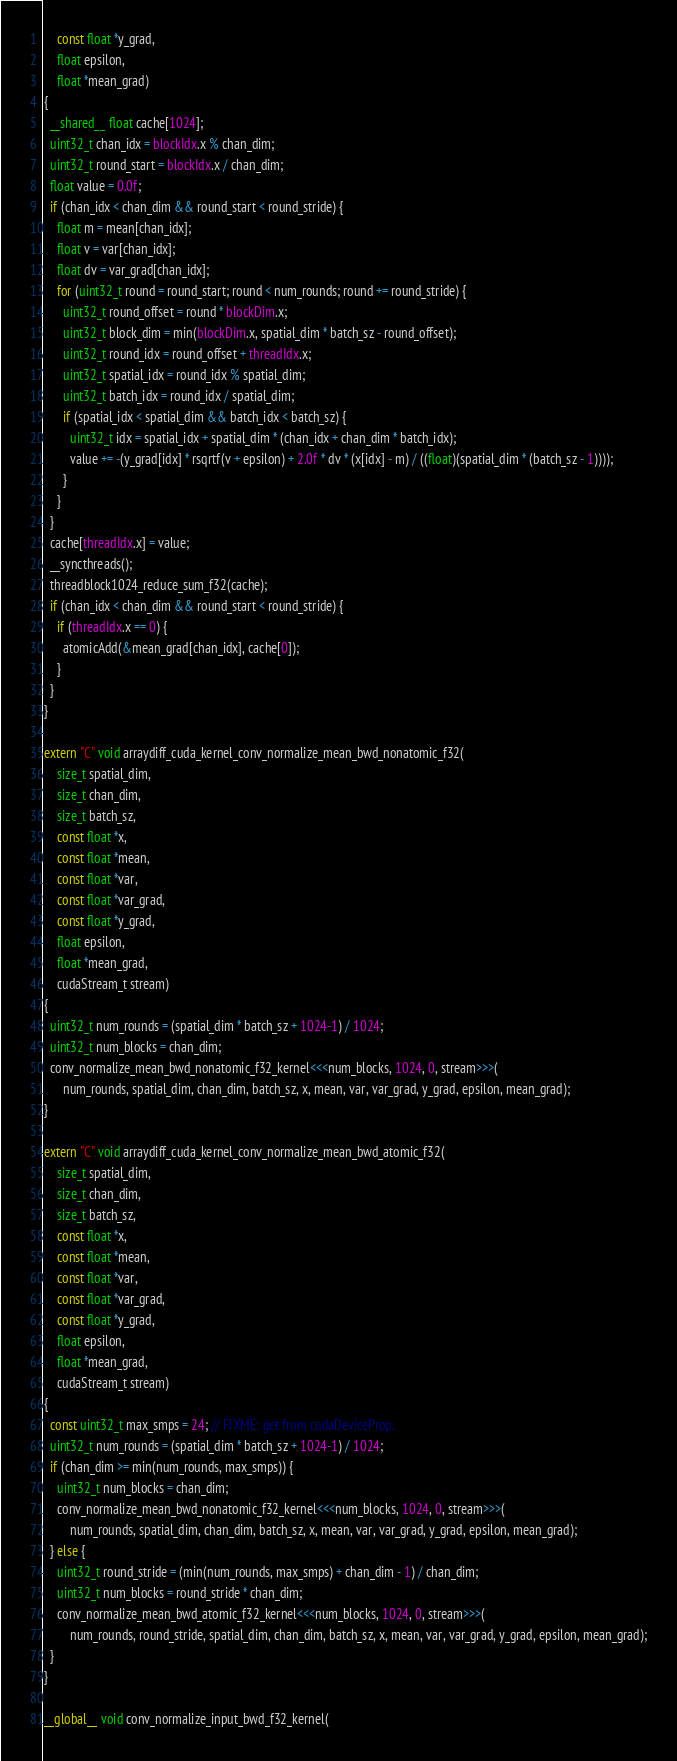Convert code to text. <code><loc_0><loc_0><loc_500><loc_500><_Cuda_>    const float *y_grad,
    float epsilon,
    float *mean_grad)
{
  __shared__ float cache[1024];
  uint32_t chan_idx = blockIdx.x % chan_dim;
  uint32_t round_start = blockIdx.x / chan_dim;
  float value = 0.0f;
  if (chan_idx < chan_dim && round_start < round_stride) {
    float m = mean[chan_idx];
    float v = var[chan_idx];
    float dv = var_grad[chan_idx];
    for (uint32_t round = round_start; round < num_rounds; round += round_stride) {
      uint32_t round_offset = round * blockDim.x;
      uint32_t block_dim = min(blockDim.x, spatial_dim * batch_sz - round_offset);
      uint32_t round_idx = round_offset + threadIdx.x;
      uint32_t spatial_idx = round_idx % spatial_dim;
      uint32_t batch_idx = round_idx / spatial_dim;
      if (spatial_idx < spatial_dim && batch_idx < batch_sz) {
        uint32_t idx = spatial_idx + spatial_dim * (chan_idx + chan_dim * batch_idx);
        value += -(y_grad[idx] * rsqrtf(v + epsilon) + 2.0f * dv * (x[idx] - m) / ((float)(spatial_dim * (batch_sz - 1))));
      }
    }
  }
  cache[threadIdx.x] = value;
  __syncthreads();
  threadblock1024_reduce_sum_f32(cache);
  if (chan_idx < chan_dim && round_start < round_stride) {
    if (threadIdx.x == 0) {
      atomicAdd(&mean_grad[chan_idx], cache[0]);
    }
  }
}

extern "C" void arraydiff_cuda_kernel_conv_normalize_mean_bwd_nonatomic_f32(
    size_t spatial_dim,
    size_t chan_dim,
    size_t batch_sz,
    const float *x,
    const float *mean,
    const float *var,
    const float *var_grad,
    const float *y_grad,
    float epsilon,
    float *mean_grad,
    cudaStream_t stream)
{
  uint32_t num_rounds = (spatial_dim * batch_sz + 1024-1) / 1024;
  uint32_t num_blocks = chan_dim;
  conv_normalize_mean_bwd_nonatomic_f32_kernel<<<num_blocks, 1024, 0, stream>>>(
      num_rounds, spatial_dim, chan_dim, batch_sz, x, mean, var, var_grad, y_grad, epsilon, mean_grad);
}

extern "C" void arraydiff_cuda_kernel_conv_normalize_mean_bwd_atomic_f32(
    size_t spatial_dim,
    size_t chan_dim,
    size_t batch_sz,
    const float *x,
    const float *mean,
    const float *var,
    const float *var_grad,
    const float *y_grad,
    float epsilon,
    float *mean_grad,
    cudaStream_t stream)
{
  const uint32_t max_smps = 24; // FIXME: get from cudaDeviceProp.
  uint32_t num_rounds = (spatial_dim * batch_sz + 1024-1) / 1024;
  if (chan_dim >= min(num_rounds, max_smps)) {
    uint32_t num_blocks = chan_dim;
    conv_normalize_mean_bwd_nonatomic_f32_kernel<<<num_blocks, 1024, 0, stream>>>(
        num_rounds, spatial_dim, chan_dim, batch_sz, x, mean, var, var_grad, y_grad, epsilon, mean_grad);
  } else {
    uint32_t round_stride = (min(num_rounds, max_smps) + chan_dim - 1) / chan_dim;
    uint32_t num_blocks = round_stride * chan_dim;
    conv_normalize_mean_bwd_atomic_f32_kernel<<<num_blocks, 1024, 0, stream>>>(
        num_rounds, round_stride, spatial_dim, chan_dim, batch_sz, x, mean, var, var_grad, y_grad, epsilon, mean_grad);
  }
}

__global__ void conv_normalize_input_bwd_f32_kernel(</code> 